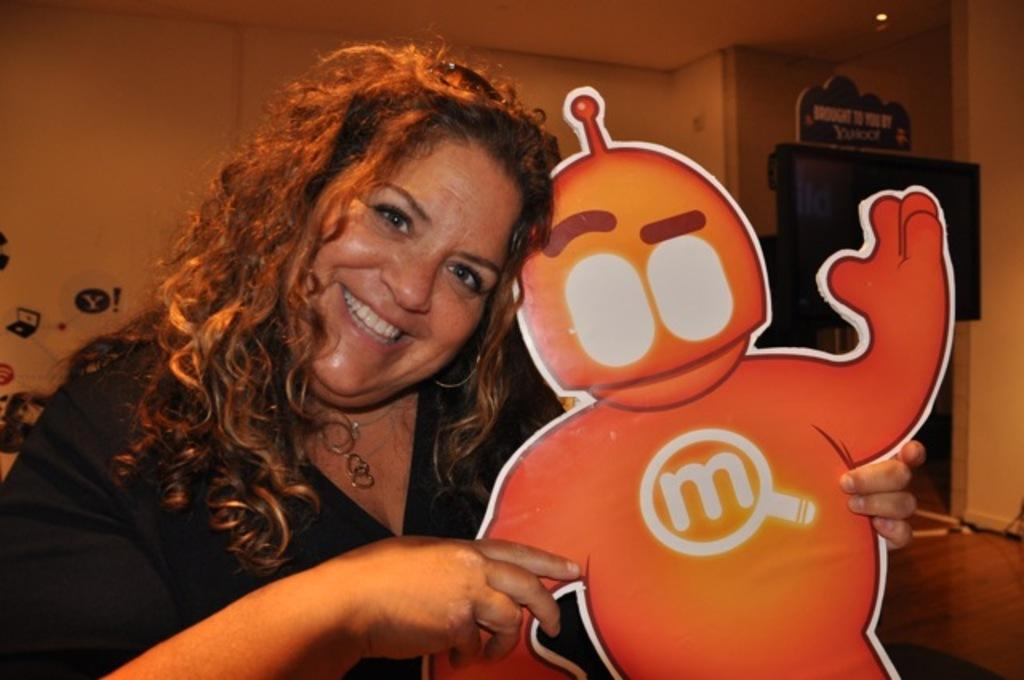<image>
Create a compact narrative representing the image presented. Woman holding a cut out of a robot that has a letter M on the chest. 